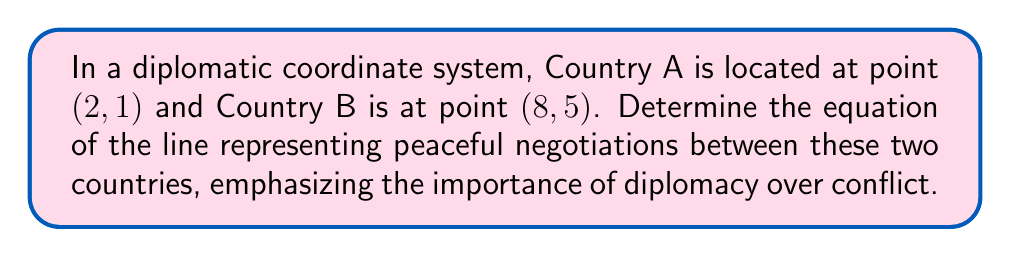Can you answer this question? To find the equation of the line representing peaceful negotiations, we'll use the point-slope form of a line equation. Here's how we proceed:

1. Identify the two points:
   Point 1 (Country A): $(x_1, y_1) = (2, 1)$
   Point 2 (Country B): $(x_2, y_2) = (8, 5)$

2. Calculate the slope (m) of the line:
   $$m = \frac{y_2 - y_1}{x_2 - x_1} = \frac{5 - 1}{8 - 2} = \frac{4}{6} = \frac{2}{3}$$

3. Use the point-slope form of a line equation:
   $y - y_1 = m(x - x_1)$

4. Substitute the values:
   $y - 1 = \frac{2}{3}(x - 2)$

5. Simplify:
   $y - 1 = \frac{2x - 4}{3}$

6. Multiply both sides by 3:
   $3(y - 1) = 2x - 4$

7. Distribute:
   $3y - 3 = 2x - 4$

8. Rearrange to standard form $Ax + By + C = 0$:
   $2x - 3y + 1 = 0$

This equation represents the line of peaceful negotiations, where each point on the line symbolizes a potential diplomatic solution between the two countries.
Answer: $2x - 3y + 1 = 0$ 